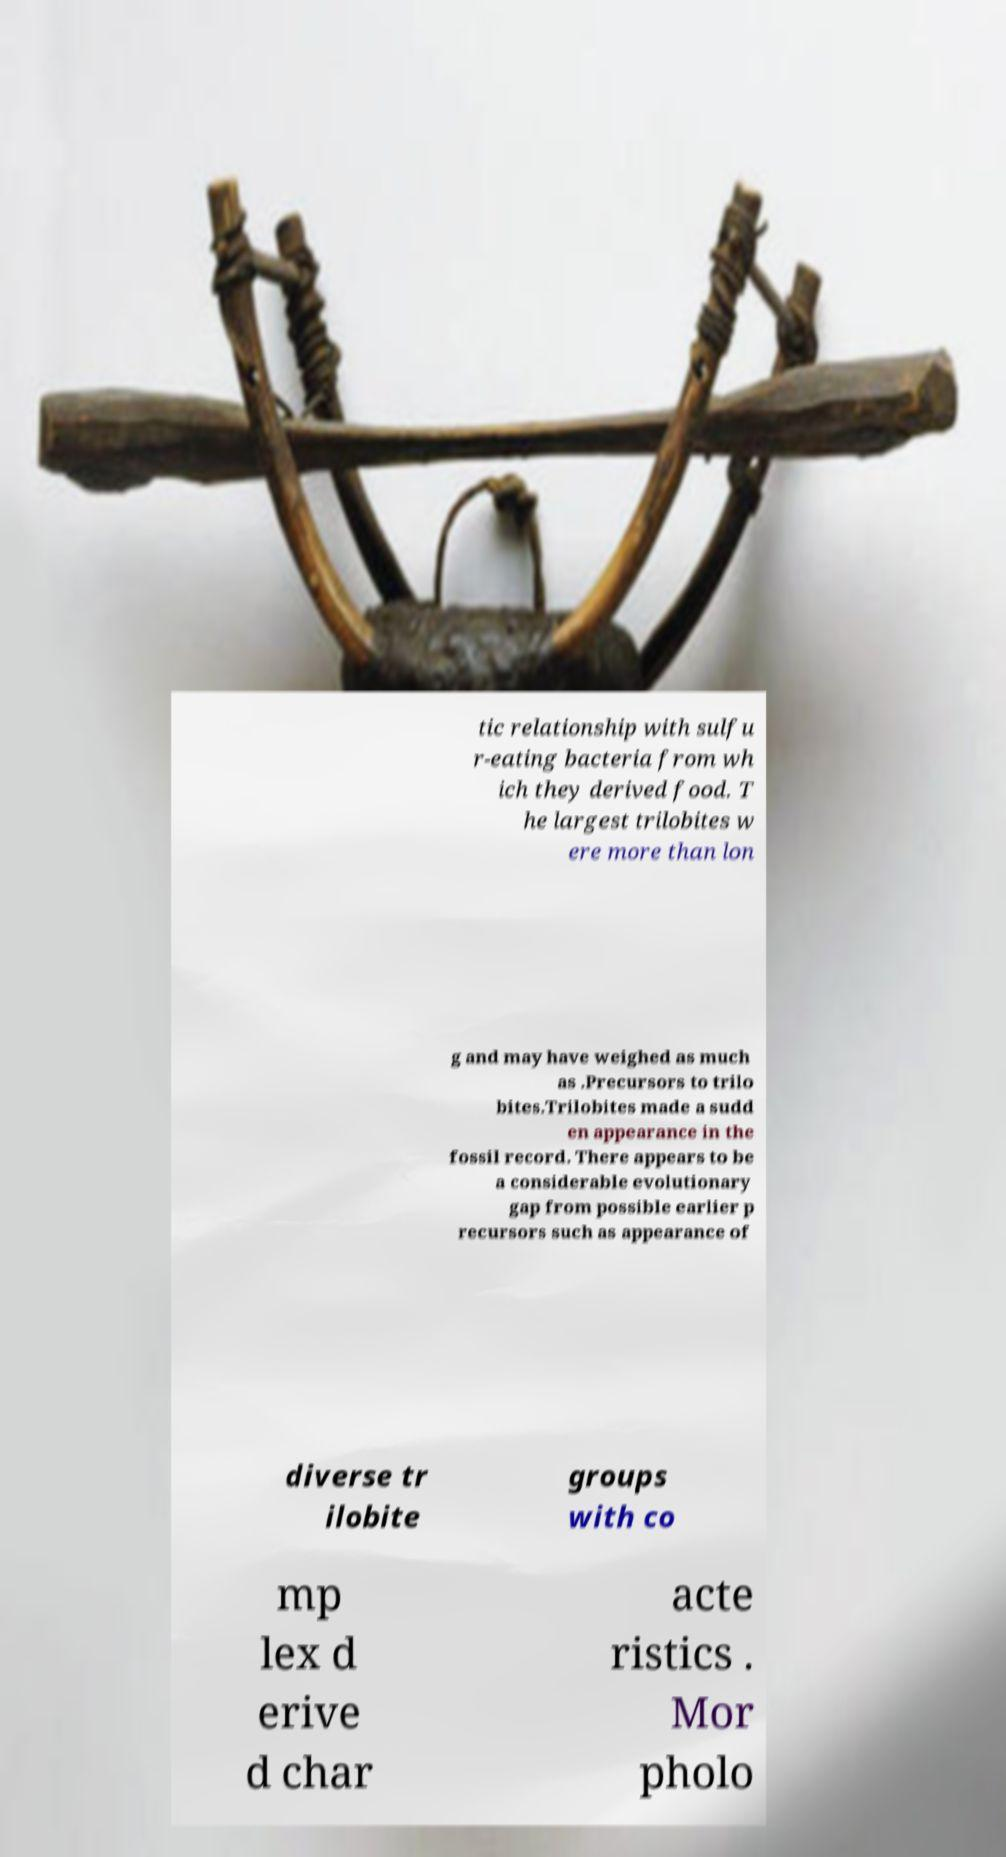Could you assist in decoding the text presented in this image and type it out clearly? tic relationship with sulfu r-eating bacteria from wh ich they derived food. T he largest trilobites w ere more than lon g and may have weighed as much as .Precursors to trilo bites.Trilobites made a sudd en appearance in the fossil record. There appears to be a considerable evolutionary gap from possible earlier p recursors such as appearance of diverse tr ilobite groups with co mp lex d erive d char acte ristics . Mor pholo 